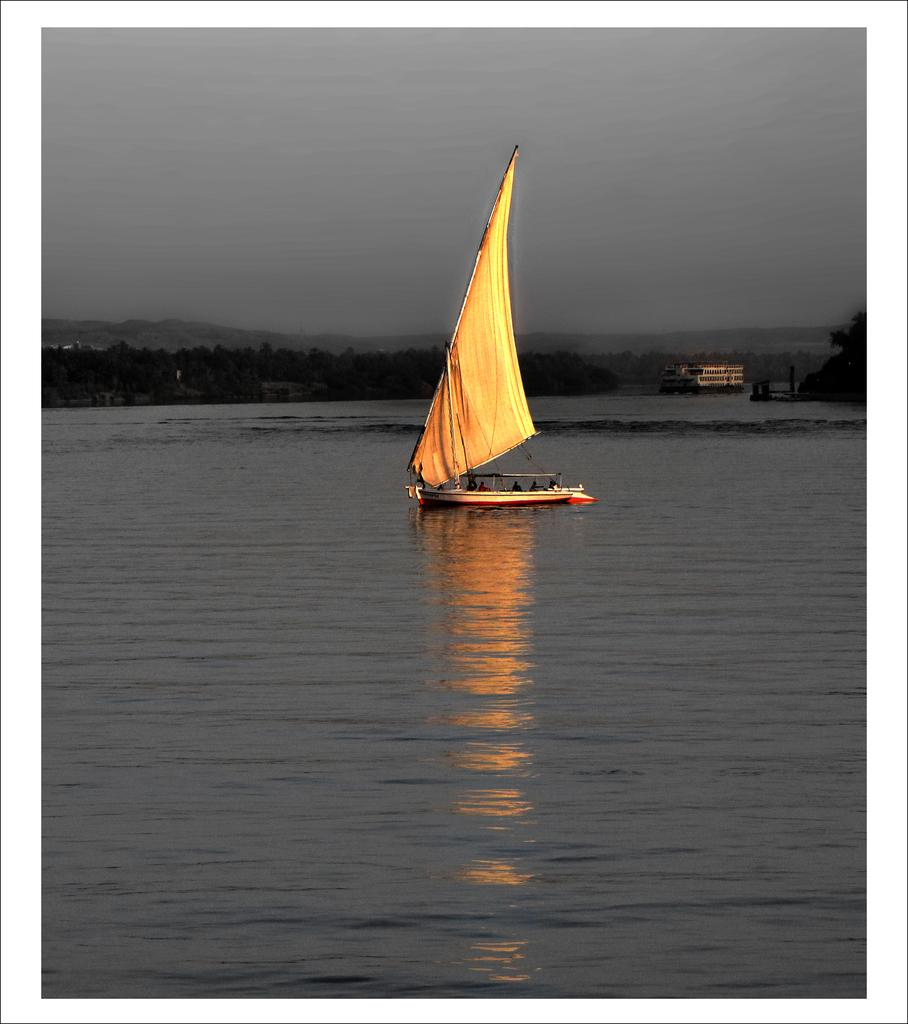What is the main subject of the image? The main subject of the image is a boat. What is the boat doing in the image? The boat is sailing on the water. What can be seen in the background of the image? There are trees and a building in the backdrop of the image. How would you describe the weather in the image? The sky is cloudy in the image. How many cherries are hanging from the trees in the image? There are no cherries visible in the image; only trees and a building can be seen in the backdrop. 